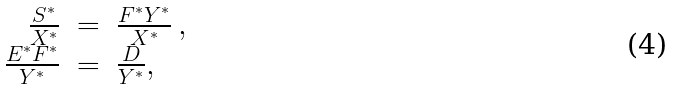<formula> <loc_0><loc_0><loc_500><loc_500>\begin{array} { r c l } \frac { S ^ { \ast } } { X ^ { \ast } } & = & \frac { F ^ { \ast } Y ^ { \ast } } { X ^ { \ast } } \, , \\ \frac { E ^ { \ast } F ^ { \ast } } { Y ^ { \ast } } & = & \frac { D } { Y ^ { \ast } } , \\ \end{array}</formula> 